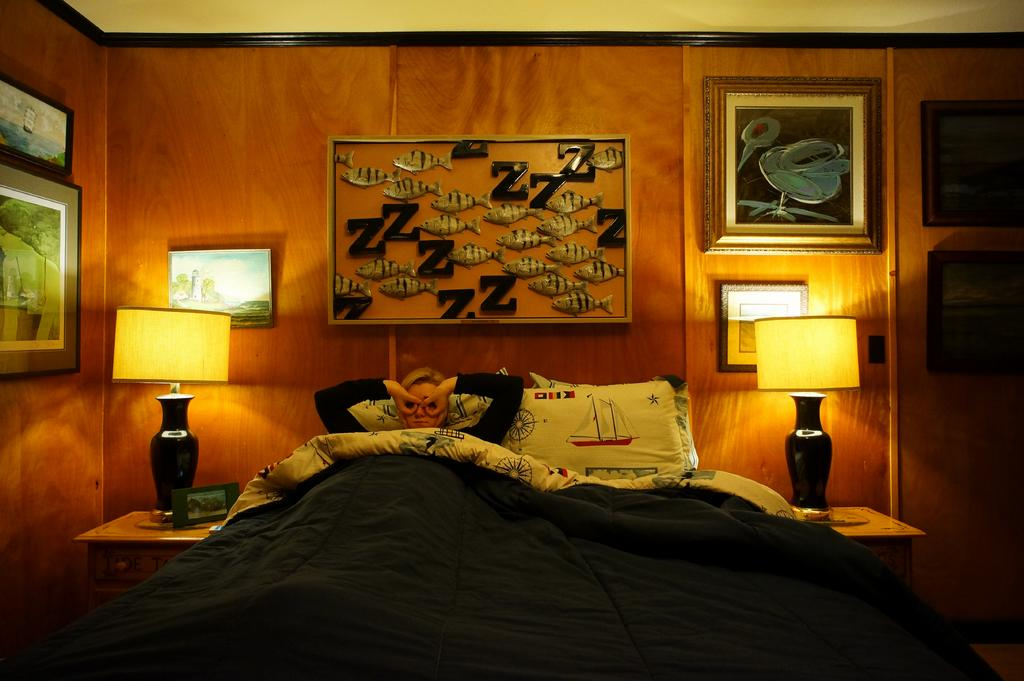What is the person doing on the bed in the image? The facts do not specify what the person is doing on the bed. What can be found on the bed besides the person? There are pillows and a bed sheet on the bed. What type of lighting is present in the image? There are lamps on tables in the image. What is located on a table in the image? There is a frame on a table. What can be seen on the wall in the background? There are frames on the wall in the background. What type of nut is being cracked on the chin of the person in the image? There is no nut or chin-cracking activity present in the image. 